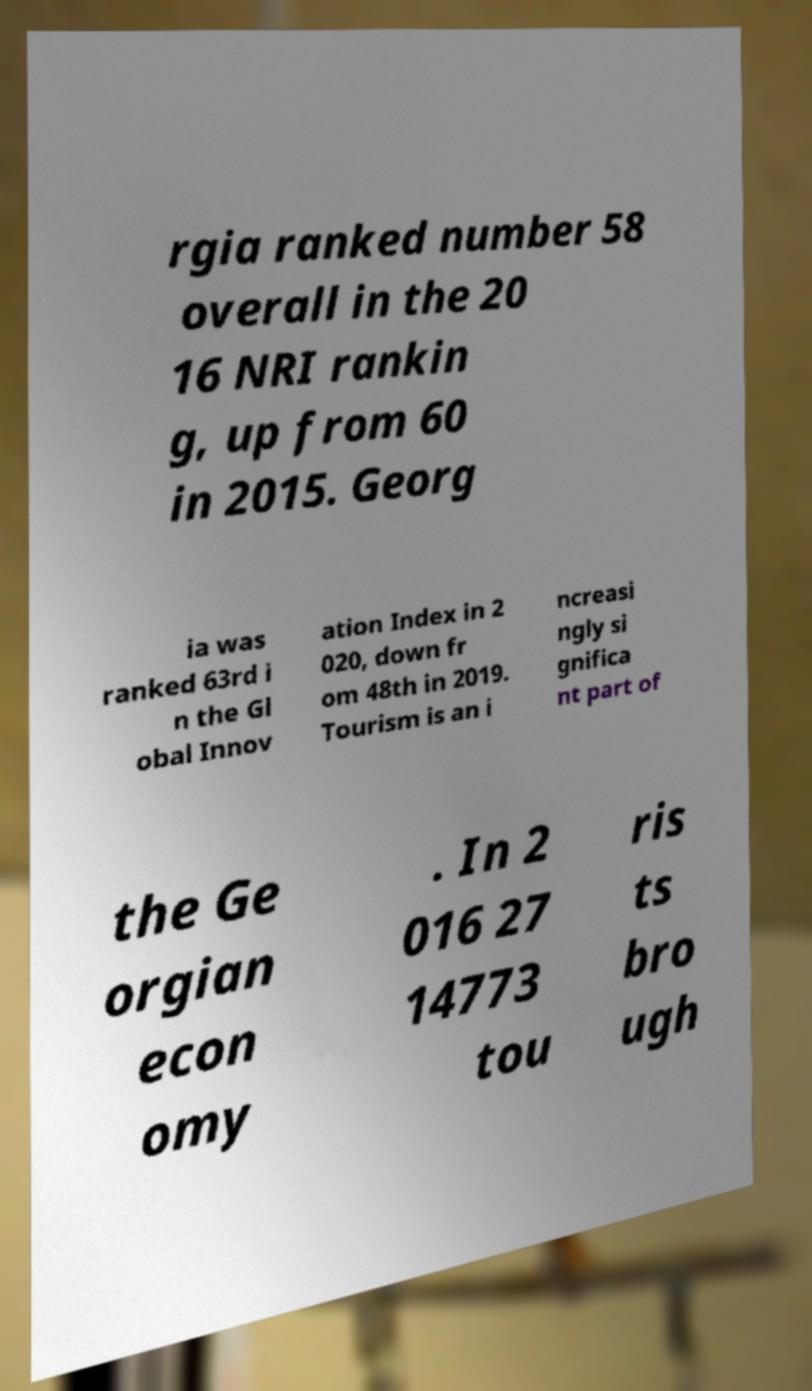Can you accurately transcribe the text from the provided image for me? rgia ranked number 58 overall in the 20 16 NRI rankin g, up from 60 in 2015. Georg ia was ranked 63rd i n the Gl obal Innov ation Index in 2 020, down fr om 48th in 2019. Tourism is an i ncreasi ngly si gnifica nt part of the Ge orgian econ omy . In 2 016 27 14773 tou ris ts bro ugh 